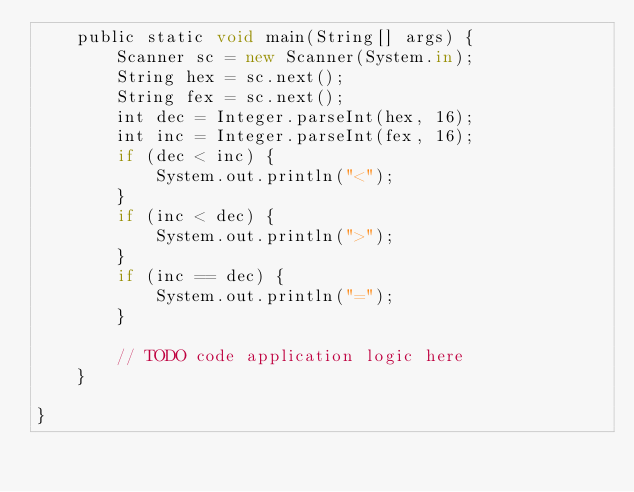<code> <loc_0><loc_0><loc_500><loc_500><_JavaScript_>    public static void main(String[] args) {
        Scanner sc = new Scanner(System.in);
        String hex = sc.next();
        String fex = sc.next();
        int dec = Integer.parseInt(hex, 16);
        int inc = Integer.parseInt(fex, 16);
        if (dec < inc) {
            System.out.println("<");
        }
        if (inc < dec) {
            System.out.println(">");
        }
        if (inc == dec) {
            System.out.println("=");
        }

        // TODO code application logic here
    }

}</code> 